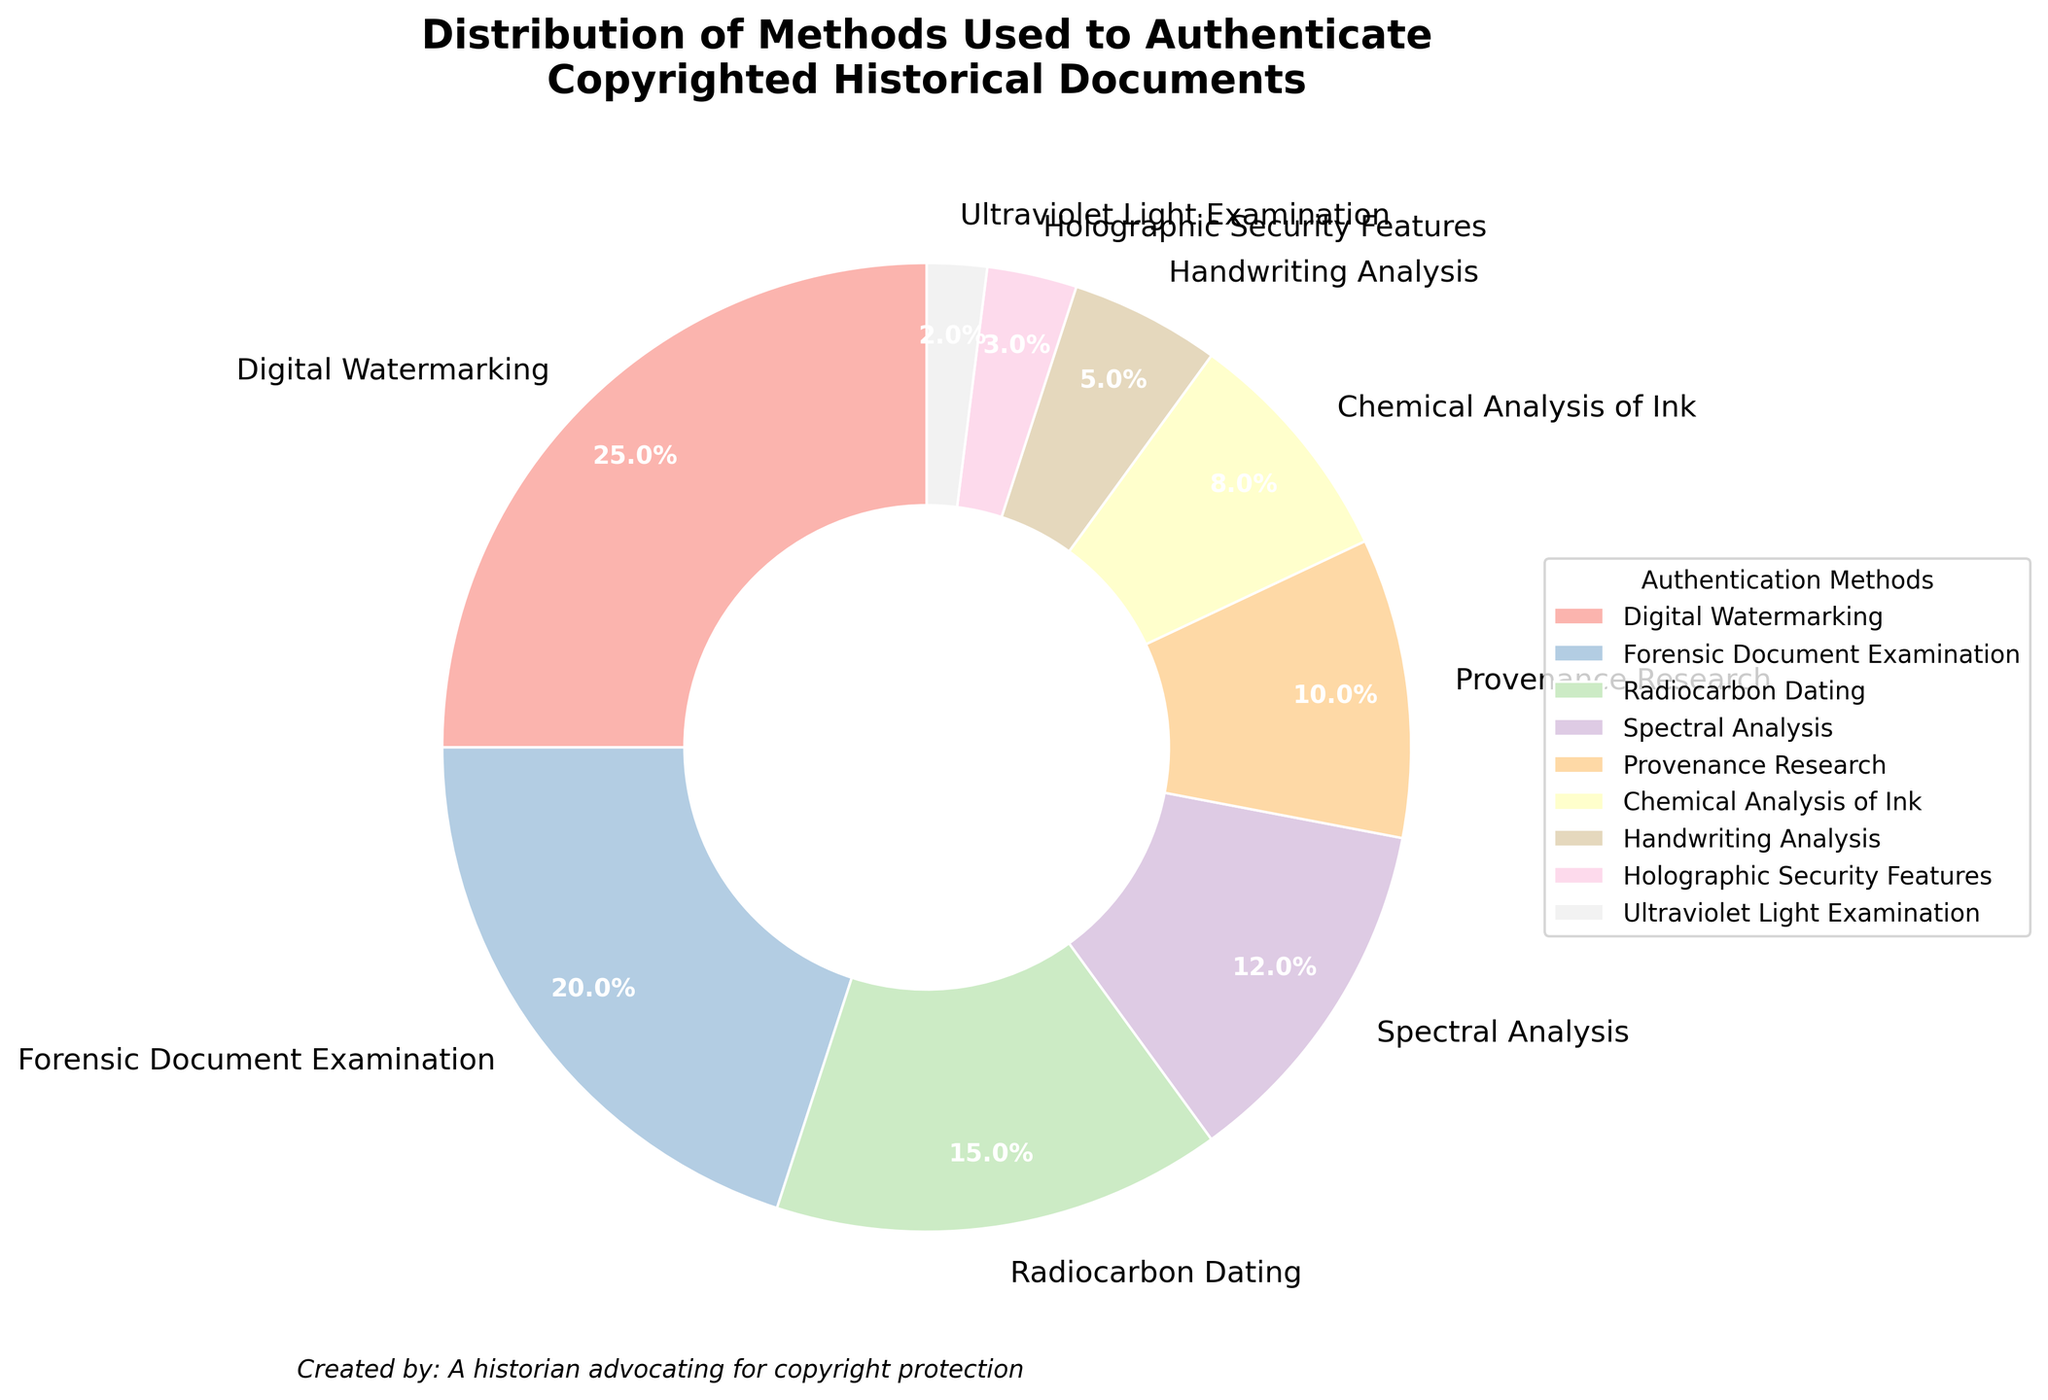Which method accounts for the largest percentage of document authentication? The chart shows each method's percentage. Notably, 'Digital Watermarking' has the largest wedge with 25%.
Answer: Digital Watermarking What is the combined percentage of Forensic Document Examination and Spectral Analysis? Combine the percentages from the chart: Forensic Document Examination (20%) + Spectral Analysis (12%) = 32%.
Answer: 32% Which method has a smaller percentage, Provenance Research or Chemical Analysis of Ink? By comparing the wedges, Provenance Research is labeled as 10% and Chemical Analysis of Ink is 8%. Hence, Chemical Analysis of Ink is smaller.
Answer: Chemical Analysis of Ink How many methods have a percentage of 10% or more? Count the wedges that have a label of 10% or more: Digital Watermarking (25%), Forensic Document Examination (20%), Radiocarbon Dating (15%), Spectral Analysis (12%), Provenance Research (10%). That's 5 methods.
Answer: 5 What is the difference in percentage between the method with the least percentage and the method with the highest percentage? The least percentage is for Ultraviolet Light Examination (2%) and the highest is Digital Watermarking (25%). The difference is 25% - 2% = 23%.
Answer: 23% List all methods whose percentage falls below the average percentage of all methods. First, compute the average percentage: (25 + 20 + 15 + 12 + 10 + 8 + 5 + 3 + 2) / 9 ≈ 11.1%. Methods below 11.1% are: Provenance Research (10%), Chemical Analysis of Ink (8%), Handwriting Analysis (5%), Holographic Security Features (3%), Ultraviolet Light Examination (2%).
Answer: Provenance Research, Chemical Analysis of Ink, Handwriting Analysis, Holographic Security Features, Ultraviolet Light Examination Which two methods together make up 30% of the total distribution? Identify and combine methods until you get 30%. Provenance Research (10%) + Chemical Analysis of Ink (8%) + Handwriting Analysis (5%) + Holographic Security Features (3%) + Ultraviolet Light Examination (2%). Each pair check sums: Forensic Document Examination (20%) + Handwriting Analysis (5%) + Holographic Security Features (3%) + Ultraviolet Light Exam (2%) = 30.
Answer: Forensic Document Examination, Handwriting Analysis What is the sum of the percentages of the three smallest methods? The three smallest sections are Ultraviolet Light Examination (2%), Holographic Security Features (3%), Handwriting Analysis (5%). Sum: 2% + 3% + 5% = 10%.
Answer: 10% 